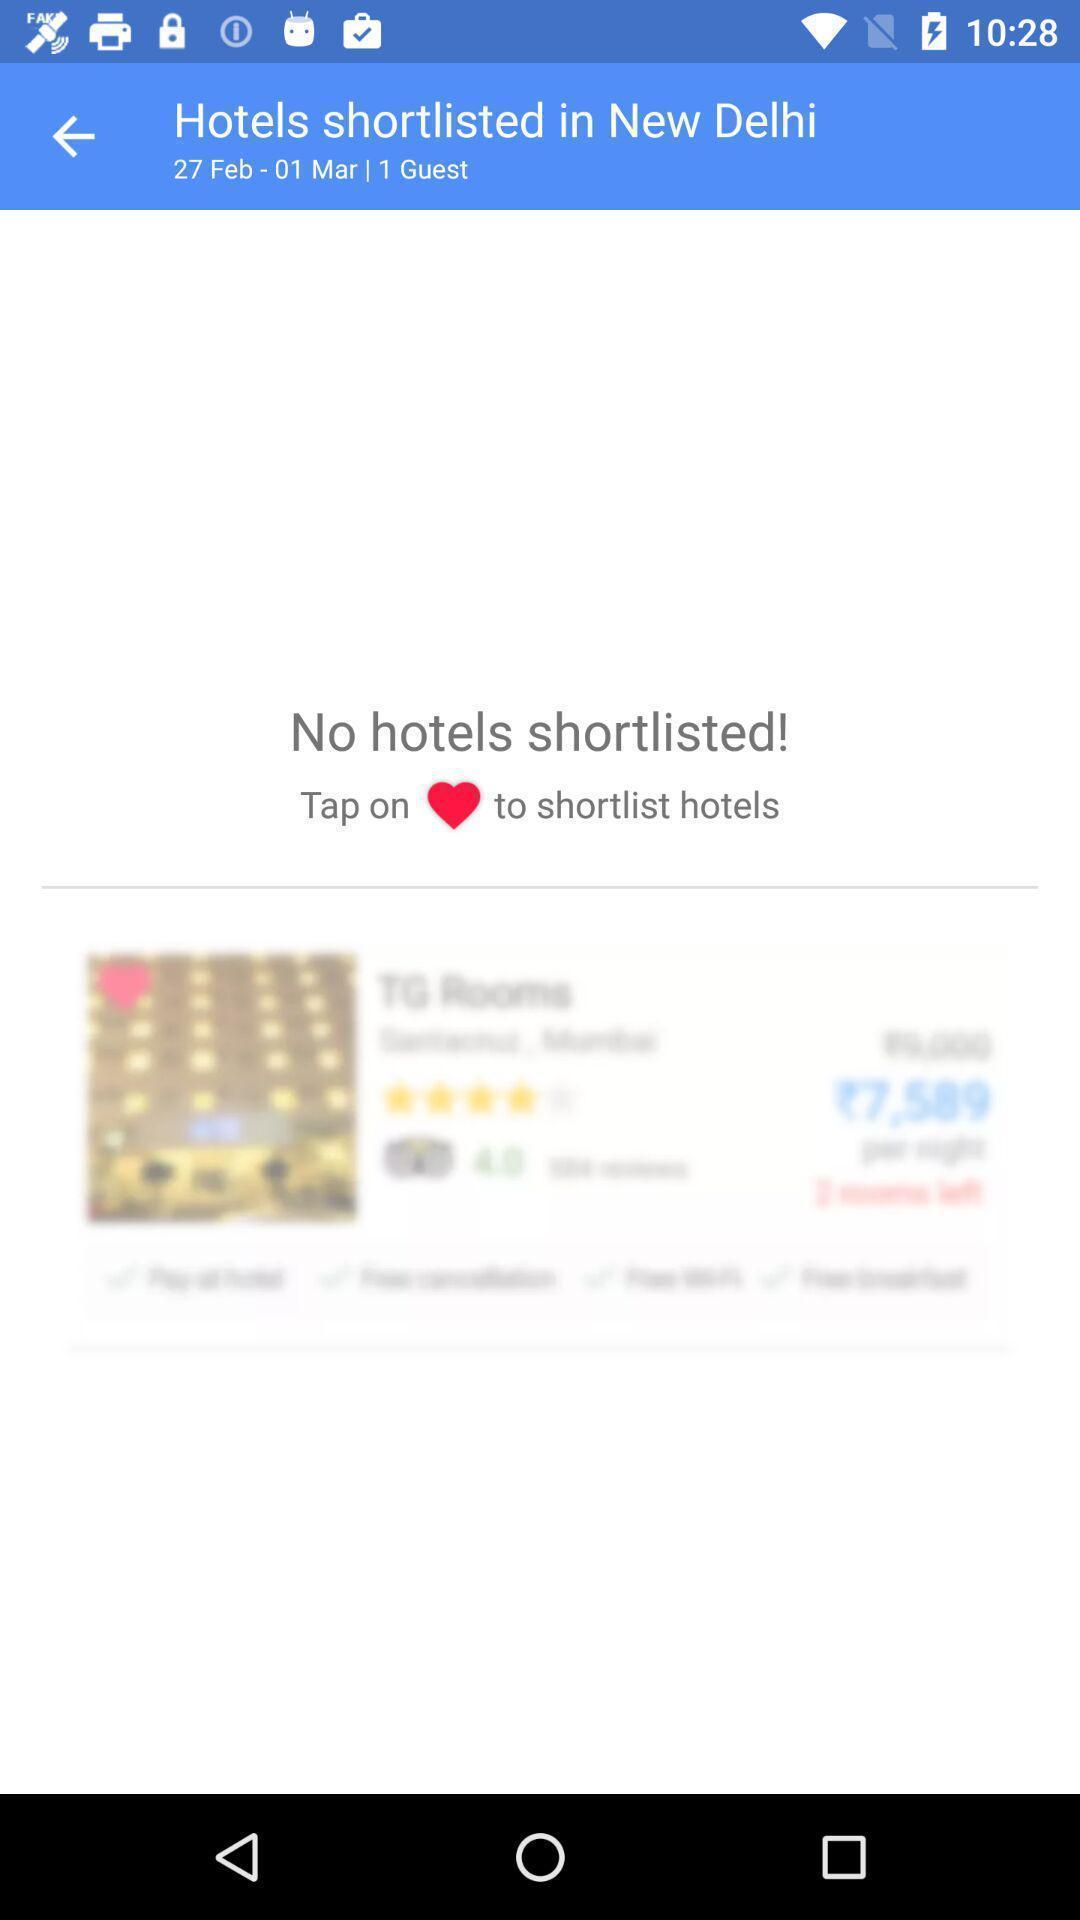Describe this image in words. Screen displaying the shortlisted hotels. 